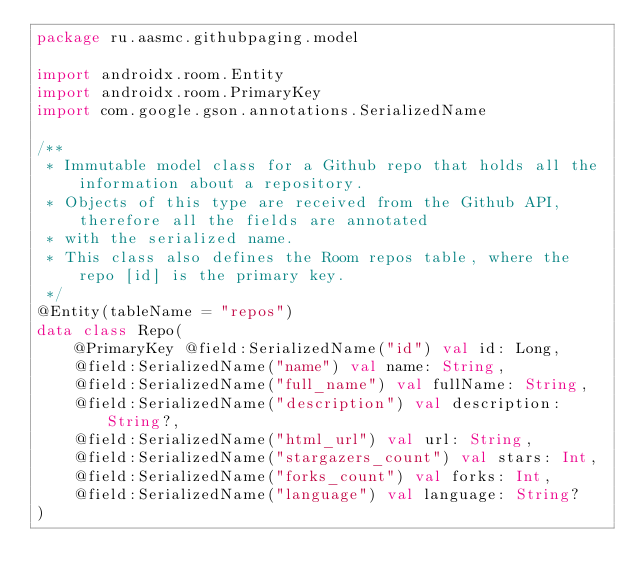Convert code to text. <code><loc_0><loc_0><loc_500><loc_500><_Kotlin_>package ru.aasmc.githubpaging.model

import androidx.room.Entity
import androidx.room.PrimaryKey
import com.google.gson.annotations.SerializedName

/**
 * Immutable model class for a Github repo that holds all the information about a repository.
 * Objects of this type are received from the Github API, therefore all the fields are annotated
 * with the serialized name.
 * This class also defines the Room repos table, where the repo [id] is the primary key.
 */
@Entity(tableName = "repos")
data class Repo(
    @PrimaryKey @field:SerializedName("id") val id: Long,
    @field:SerializedName("name") val name: String,
    @field:SerializedName("full_name") val fullName: String,
    @field:SerializedName("description") val description: String?,
    @field:SerializedName("html_url") val url: String,
    @field:SerializedName("stargazers_count") val stars: Int,
    @field:SerializedName("forks_count") val forks: Int,
    @field:SerializedName("language") val language: String?
)
</code> 